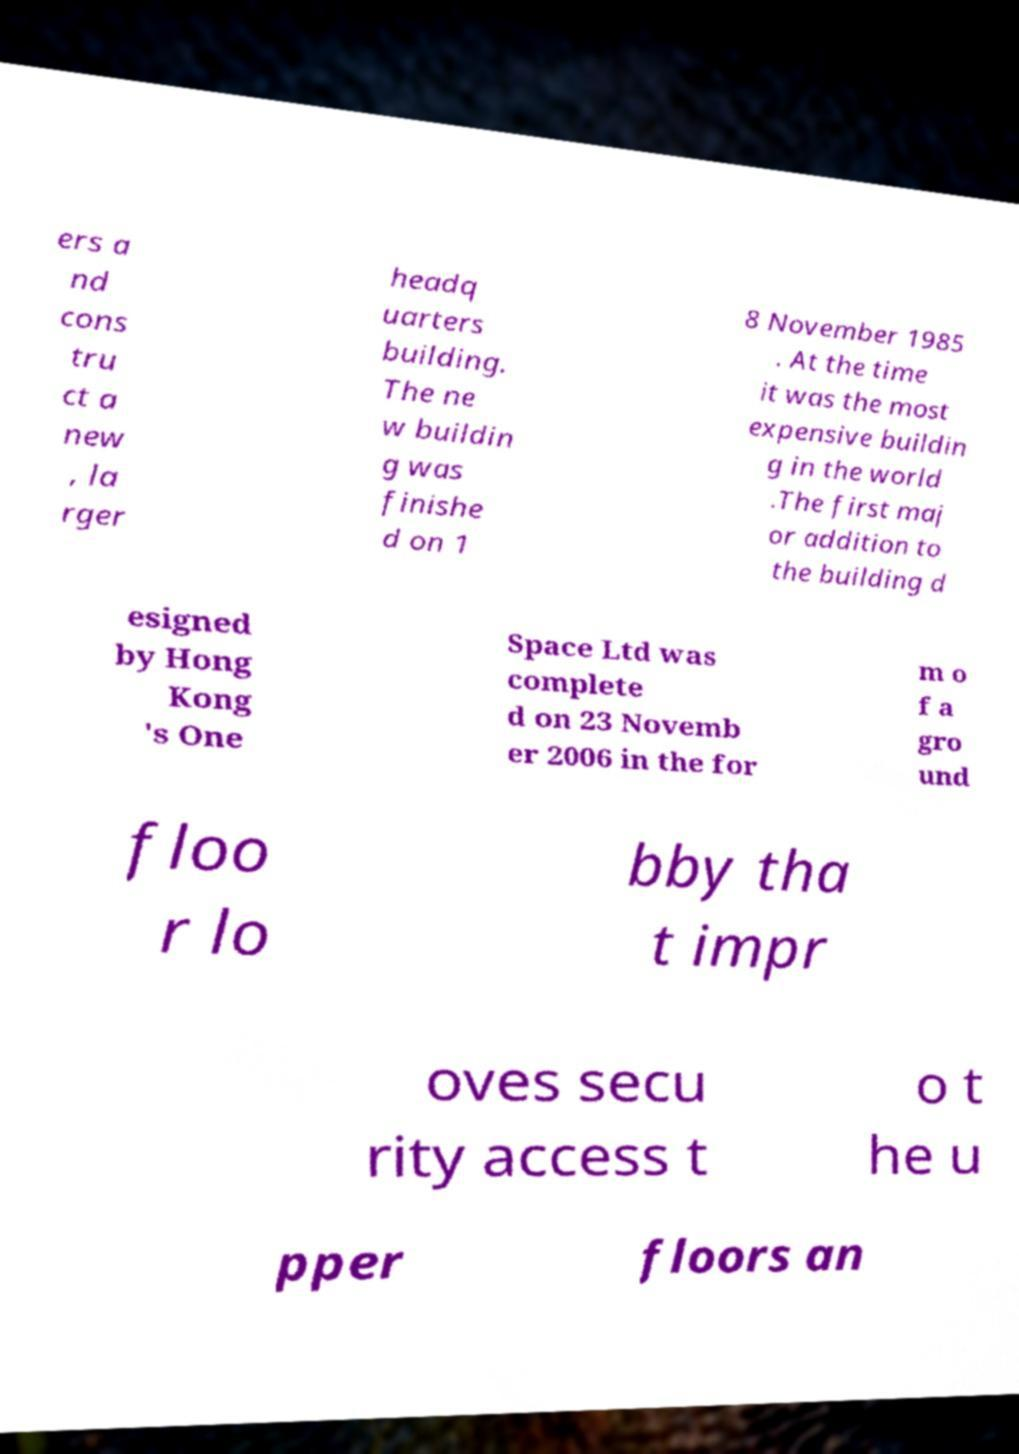Could you extract and type out the text from this image? ers a nd cons tru ct a new , la rger headq uarters building. The ne w buildin g was finishe d on 1 8 November 1985 . At the time it was the most expensive buildin g in the world .The first maj or addition to the building d esigned by Hong Kong 's One Space Ltd was complete d on 23 Novemb er 2006 in the for m o f a gro und floo r lo bby tha t impr oves secu rity access t o t he u pper floors an 